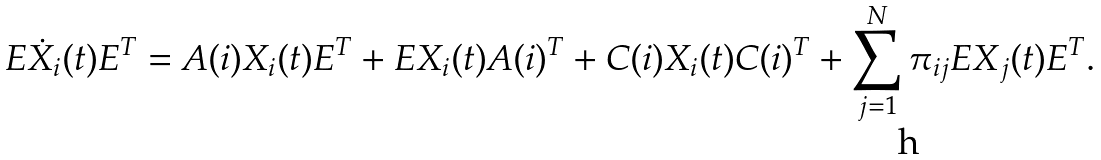<formula> <loc_0><loc_0><loc_500><loc_500>E \dot { X } _ { i } ( t ) E ^ { T } = A ( i ) X _ { i } ( t ) E ^ { T } + E X _ { i } ( t ) A ( i ) ^ { T } + C ( i ) X _ { i } ( t ) C ( i ) ^ { T } + \sum _ { j = 1 } ^ { N } \pi _ { i j } E X _ { j } ( t ) E ^ { T } .</formula> 